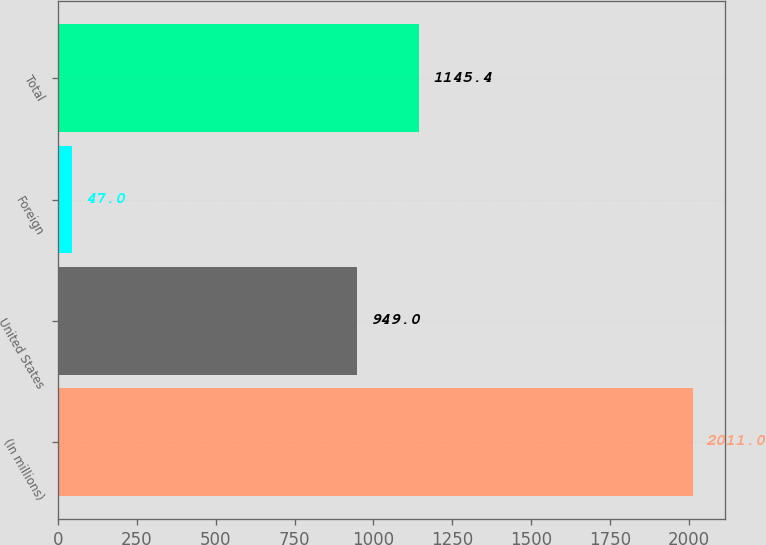Convert chart. <chart><loc_0><loc_0><loc_500><loc_500><bar_chart><fcel>(In millions)<fcel>United States<fcel>Foreign<fcel>Total<nl><fcel>2011<fcel>949<fcel>47<fcel>1145.4<nl></chart> 